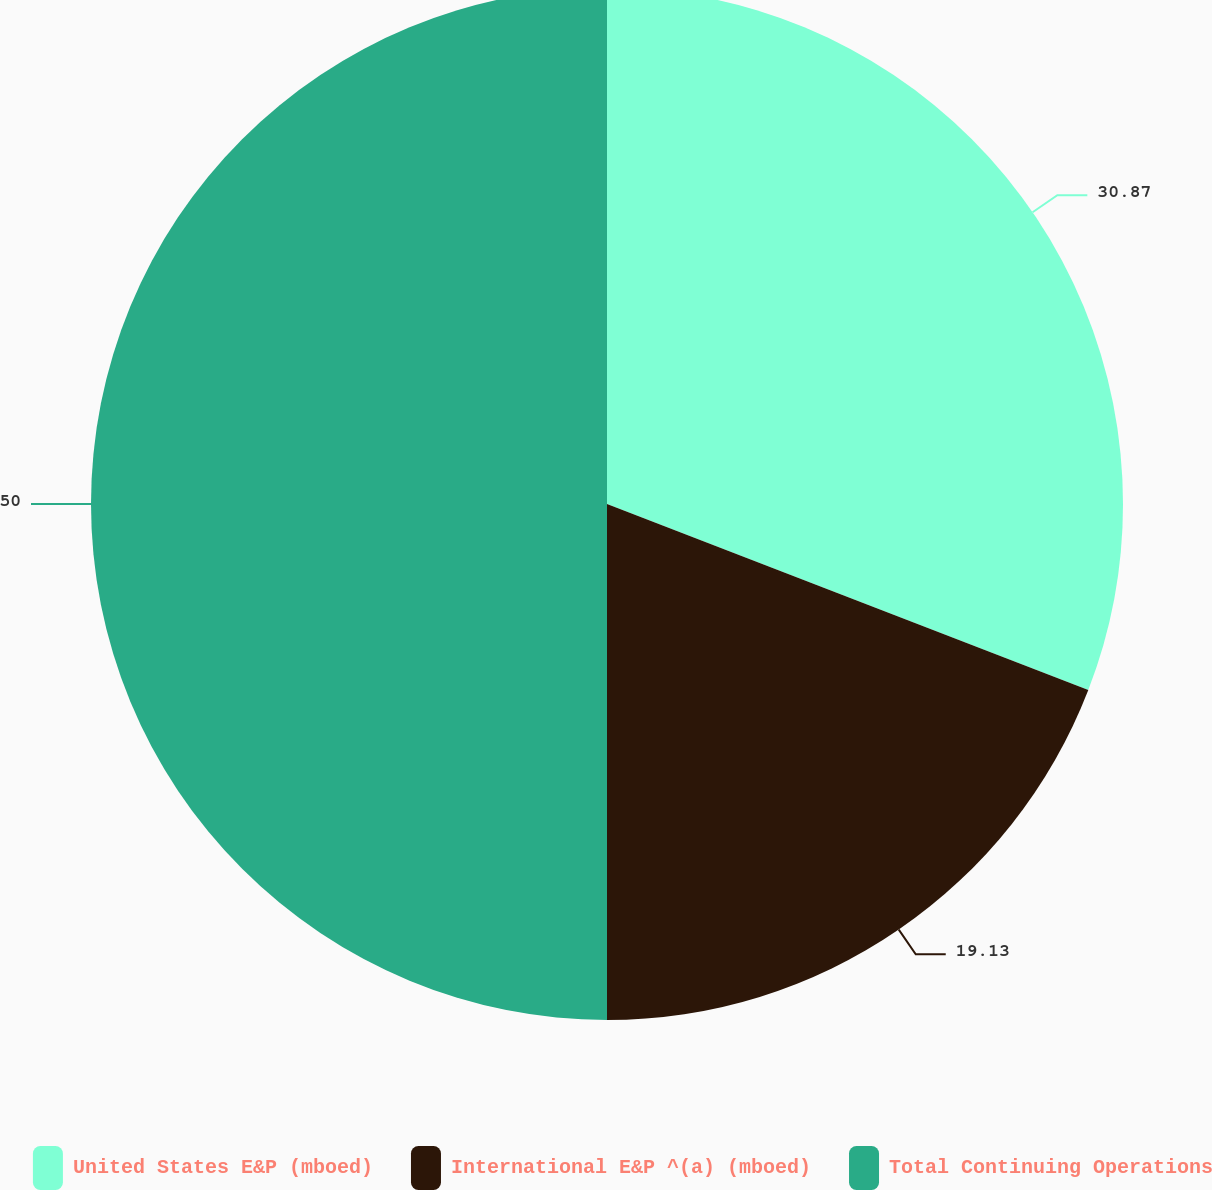<chart> <loc_0><loc_0><loc_500><loc_500><pie_chart><fcel>United States E&P (mboed)<fcel>International E&P ^(a) (mboed)<fcel>Total Continuing Operations<nl><fcel>30.87%<fcel>19.13%<fcel>50.0%<nl></chart> 